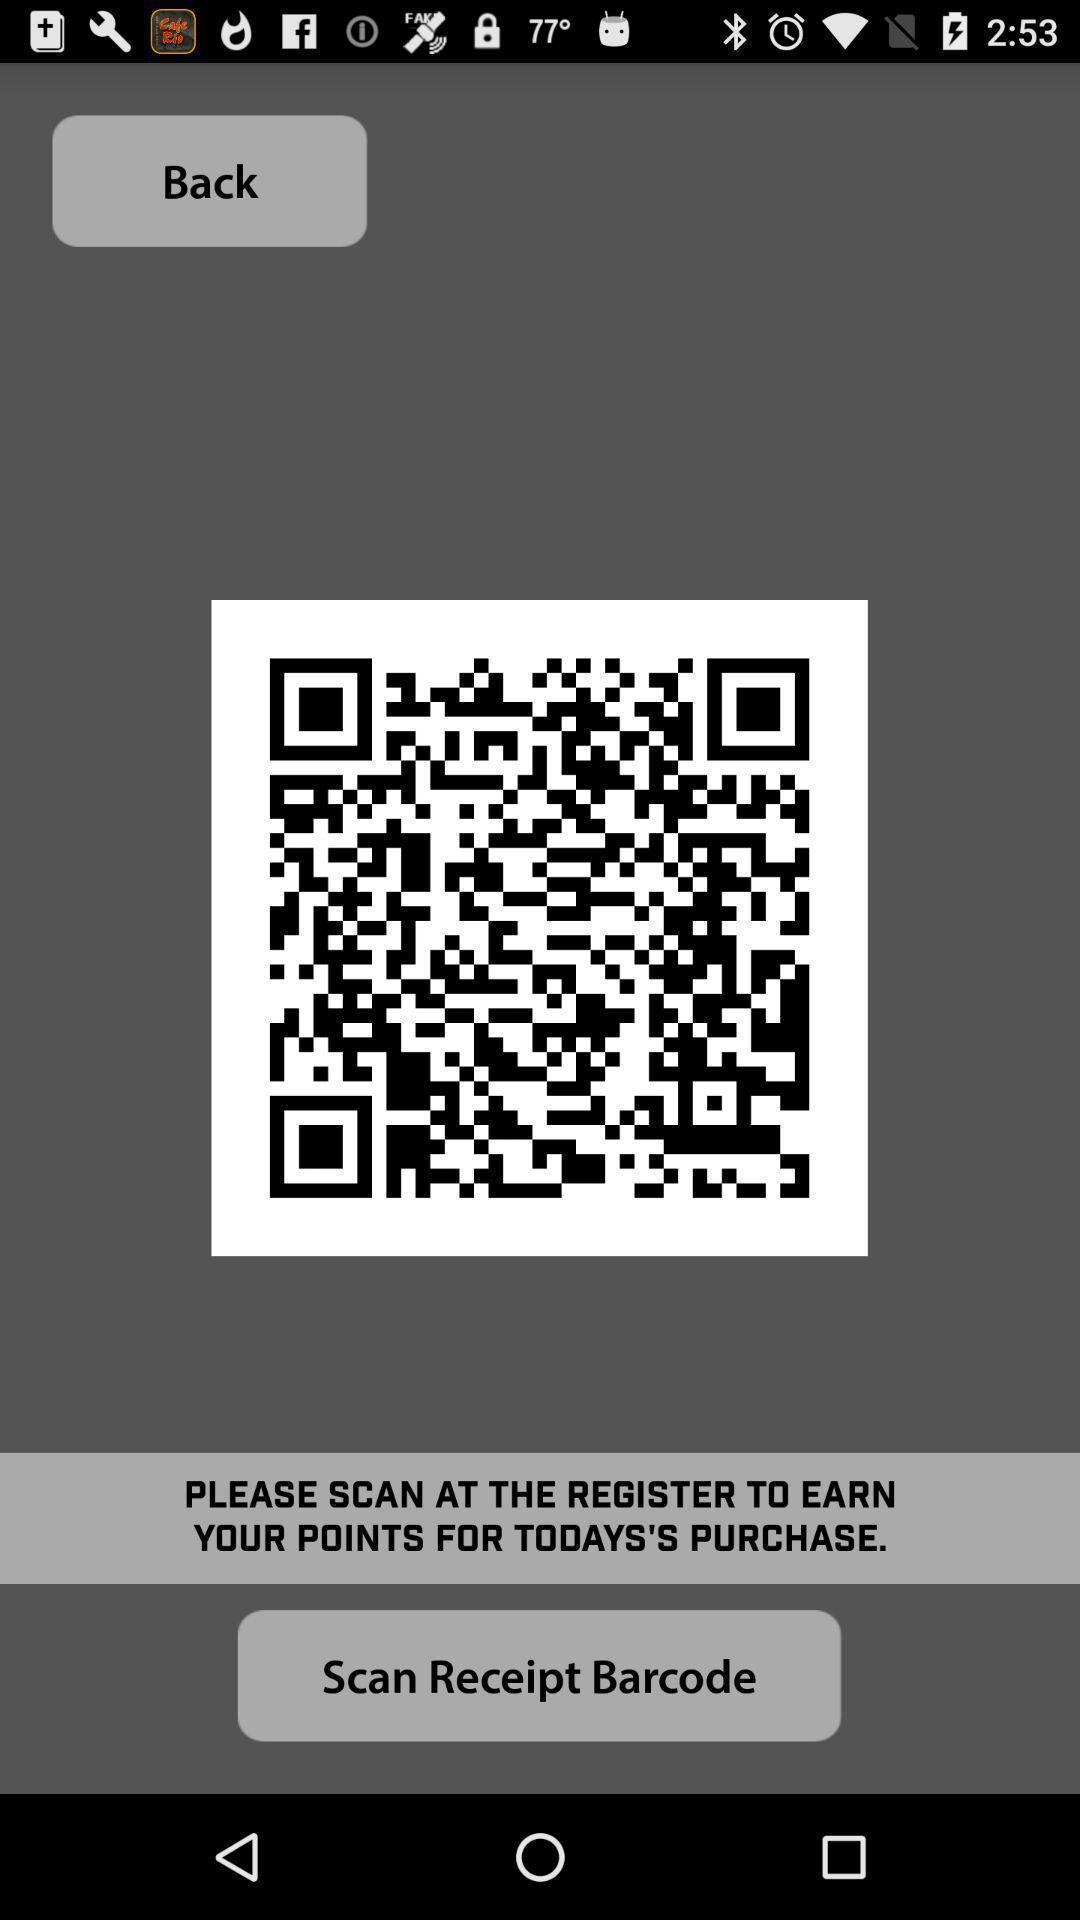Describe the content in this image. Screen page displaying the bar-code. 